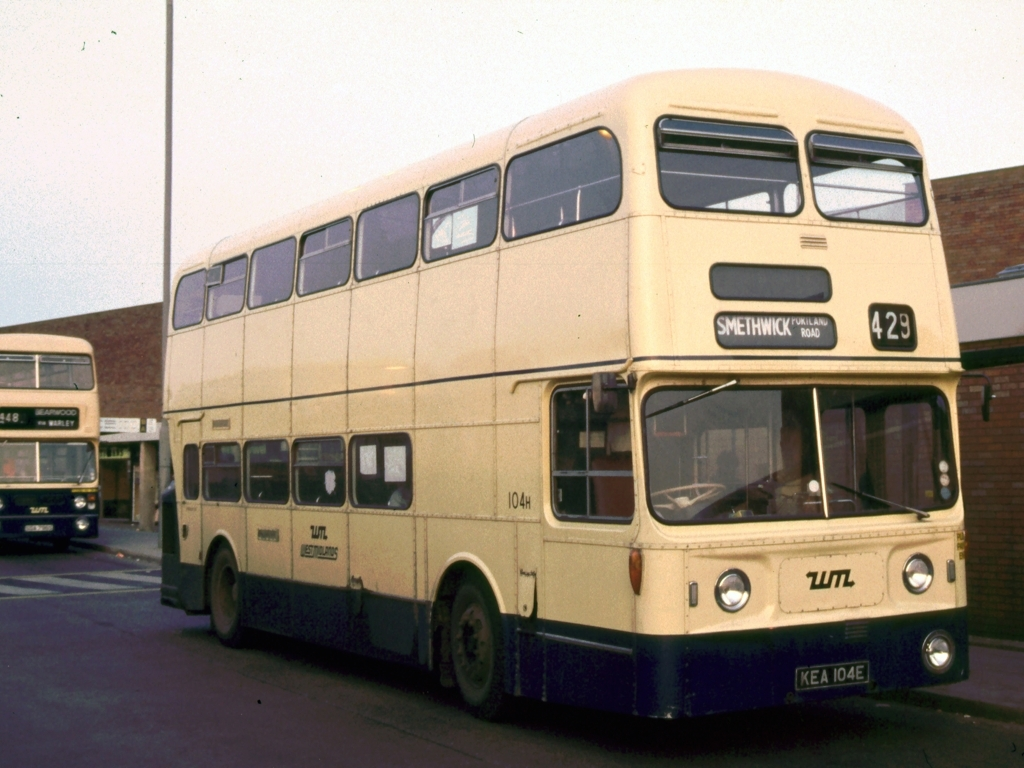What era does this bus appear to be from? The bus in the image seems to be from the mid-20th century, judging by its design and styling which were common in buses used during the 1960s and 1970s. 